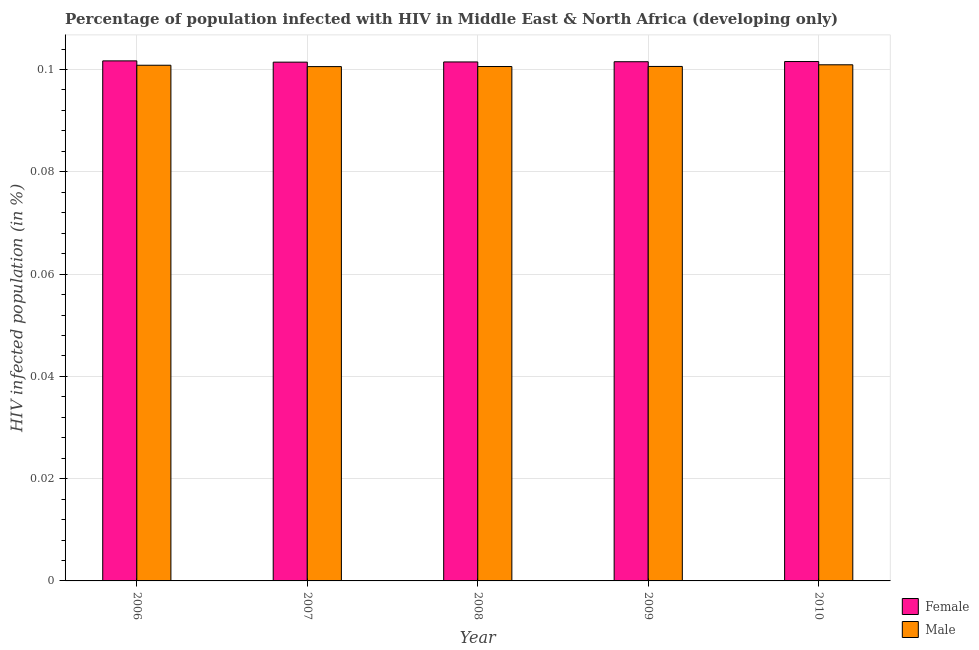Are the number of bars per tick equal to the number of legend labels?
Provide a short and direct response. Yes. Are the number of bars on each tick of the X-axis equal?
Ensure brevity in your answer.  Yes. How many bars are there on the 5th tick from the right?
Your answer should be very brief. 2. In how many cases, is the number of bars for a given year not equal to the number of legend labels?
Keep it short and to the point. 0. What is the percentage of females who are infected with hiv in 2008?
Your response must be concise. 0.1. Across all years, what is the maximum percentage of females who are infected with hiv?
Your answer should be compact. 0.1. Across all years, what is the minimum percentage of females who are infected with hiv?
Your answer should be compact. 0.1. What is the total percentage of males who are infected with hiv in the graph?
Ensure brevity in your answer.  0.5. What is the difference between the percentage of males who are infected with hiv in 2007 and that in 2008?
Provide a short and direct response. -1.6390418056996814e-5. What is the difference between the percentage of females who are infected with hiv in 2007 and the percentage of males who are infected with hiv in 2009?
Give a very brief answer. -8.140070554600587e-5. What is the average percentage of males who are infected with hiv per year?
Your answer should be compact. 0.1. In the year 2006, what is the difference between the percentage of males who are infected with hiv and percentage of females who are infected with hiv?
Your answer should be very brief. 0. What is the ratio of the percentage of males who are infected with hiv in 2006 to that in 2010?
Make the answer very short. 1. Is the difference between the percentage of males who are infected with hiv in 2007 and 2008 greater than the difference between the percentage of females who are infected with hiv in 2007 and 2008?
Make the answer very short. No. What is the difference between the highest and the second highest percentage of males who are infected with hiv?
Keep it short and to the point. 8.966340553299978e-5. What is the difference between the highest and the lowest percentage of females who are infected with hiv?
Your answer should be compact. 0. What does the 1st bar from the right in 2008 represents?
Make the answer very short. Male. How many bars are there?
Give a very brief answer. 10. What is the difference between two consecutive major ticks on the Y-axis?
Give a very brief answer. 0.02. Does the graph contain any zero values?
Offer a very short reply. No. Does the graph contain grids?
Offer a terse response. Yes. How many legend labels are there?
Ensure brevity in your answer.  2. What is the title of the graph?
Offer a terse response. Percentage of population infected with HIV in Middle East & North Africa (developing only). What is the label or title of the X-axis?
Ensure brevity in your answer.  Year. What is the label or title of the Y-axis?
Offer a terse response. HIV infected population (in %). What is the HIV infected population (in %) in Female in 2006?
Give a very brief answer. 0.1. What is the HIV infected population (in %) of Male in 2006?
Make the answer very short. 0.1. What is the HIV infected population (in %) of Female in 2007?
Provide a succinct answer. 0.1. What is the HIV infected population (in %) of Male in 2007?
Keep it short and to the point. 0.1. What is the HIV infected population (in %) in Female in 2008?
Give a very brief answer. 0.1. What is the HIV infected population (in %) in Male in 2008?
Provide a short and direct response. 0.1. What is the HIV infected population (in %) of Female in 2009?
Your answer should be compact. 0.1. What is the HIV infected population (in %) in Male in 2009?
Offer a terse response. 0.1. What is the HIV infected population (in %) in Female in 2010?
Make the answer very short. 0.1. What is the HIV infected population (in %) in Male in 2010?
Make the answer very short. 0.1. Across all years, what is the maximum HIV infected population (in %) of Female?
Offer a very short reply. 0.1. Across all years, what is the maximum HIV infected population (in %) of Male?
Give a very brief answer. 0.1. Across all years, what is the minimum HIV infected population (in %) in Female?
Make the answer very short. 0.1. Across all years, what is the minimum HIV infected population (in %) of Male?
Your answer should be compact. 0.1. What is the total HIV infected population (in %) in Female in the graph?
Your answer should be very brief. 0.51. What is the total HIV infected population (in %) in Male in the graph?
Provide a succinct answer. 0.5. What is the difference between the HIV infected population (in %) of Female in 2006 and that in 2009?
Offer a terse response. 0. What is the difference between the HIV infected population (in %) in Male in 2006 and that in 2010?
Give a very brief answer. -0. What is the difference between the HIV infected population (in %) in Male in 2007 and that in 2008?
Your answer should be compact. -0. What is the difference between the HIV infected population (in %) in Female in 2007 and that in 2009?
Offer a terse response. -0. What is the difference between the HIV infected population (in %) in Female in 2007 and that in 2010?
Ensure brevity in your answer.  -0. What is the difference between the HIV infected population (in %) in Male in 2007 and that in 2010?
Your answer should be compact. -0. What is the difference between the HIV infected population (in %) of Female in 2008 and that in 2010?
Provide a short and direct response. -0. What is the difference between the HIV infected population (in %) in Male in 2008 and that in 2010?
Make the answer very short. -0. What is the difference between the HIV infected population (in %) in Female in 2009 and that in 2010?
Provide a succinct answer. -0. What is the difference between the HIV infected population (in %) in Male in 2009 and that in 2010?
Provide a succinct answer. -0. What is the difference between the HIV infected population (in %) in Female in 2006 and the HIV infected population (in %) in Male in 2007?
Offer a terse response. 0. What is the difference between the HIV infected population (in %) in Female in 2006 and the HIV infected population (in %) in Male in 2008?
Your answer should be very brief. 0. What is the difference between the HIV infected population (in %) in Female in 2006 and the HIV infected population (in %) in Male in 2009?
Provide a short and direct response. 0. What is the difference between the HIV infected population (in %) in Female in 2006 and the HIV infected population (in %) in Male in 2010?
Give a very brief answer. 0. What is the difference between the HIV infected population (in %) in Female in 2007 and the HIV infected population (in %) in Male in 2008?
Provide a short and direct response. 0. What is the difference between the HIV infected population (in %) of Female in 2007 and the HIV infected population (in %) of Male in 2009?
Offer a very short reply. 0. What is the difference between the HIV infected population (in %) in Female in 2008 and the HIV infected population (in %) in Male in 2009?
Give a very brief answer. 0. What is the difference between the HIV infected population (in %) in Female in 2008 and the HIV infected population (in %) in Male in 2010?
Your response must be concise. 0. What is the difference between the HIV infected population (in %) of Female in 2009 and the HIV infected population (in %) of Male in 2010?
Your response must be concise. 0. What is the average HIV infected population (in %) in Female per year?
Your answer should be very brief. 0.1. What is the average HIV infected population (in %) in Male per year?
Your answer should be compact. 0.1. In the year 2006, what is the difference between the HIV infected population (in %) in Female and HIV infected population (in %) in Male?
Offer a very short reply. 0. In the year 2007, what is the difference between the HIV infected population (in %) of Female and HIV infected population (in %) of Male?
Provide a short and direct response. 0. In the year 2008, what is the difference between the HIV infected population (in %) in Female and HIV infected population (in %) in Male?
Your answer should be compact. 0. In the year 2009, what is the difference between the HIV infected population (in %) in Female and HIV infected population (in %) in Male?
Offer a very short reply. 0. In the year 2010, what is the difference between the HIV infected population (in %) of Female and HIV infected population (in %) of Male?
Make the answer very short. 0. What is the ratio of the HIV infected population (in %) in Female in 2006 to that in 2007?
Offer a very short reply. 1. What is the ratio of the HIV infected population (in %) of Female in 2006 to that in 2008?
Offer a terse response. 1. What is the ratio of the HIV infected population (in %) of Male in 2006 to that in 2008?
Your response must be concise. 1. What is the ratio of the HIV infected population (in %) in Male in 2006 to that in 2009?
Offer a terse response. 1. What is the ratio of the HIV infected population (in %) of Female in 2006 to that in 2010?
Offer a terse response. 1. What is the ratio of the HIV infected population (in %) of Female in 2007 to that in 2008?
Offer a very short reply. 1. What is the ratio of the HIV infected population (in %) in Male in 2007 to that in 2008?
Ensure brevity in your answer.  1. What is the ratio of the HIV infected population (in %) of Male in 2007 to that in 2009?
Provide a succinct answer. 1. What is the ratio of the HIV infected population (in %) in Female in 2008 to that in 2010?
Your answer should be very brief. 1. What is the difference between the highest and the second highest HIV infected population (in %) in Male?
Keep it short and to the point. 0. 